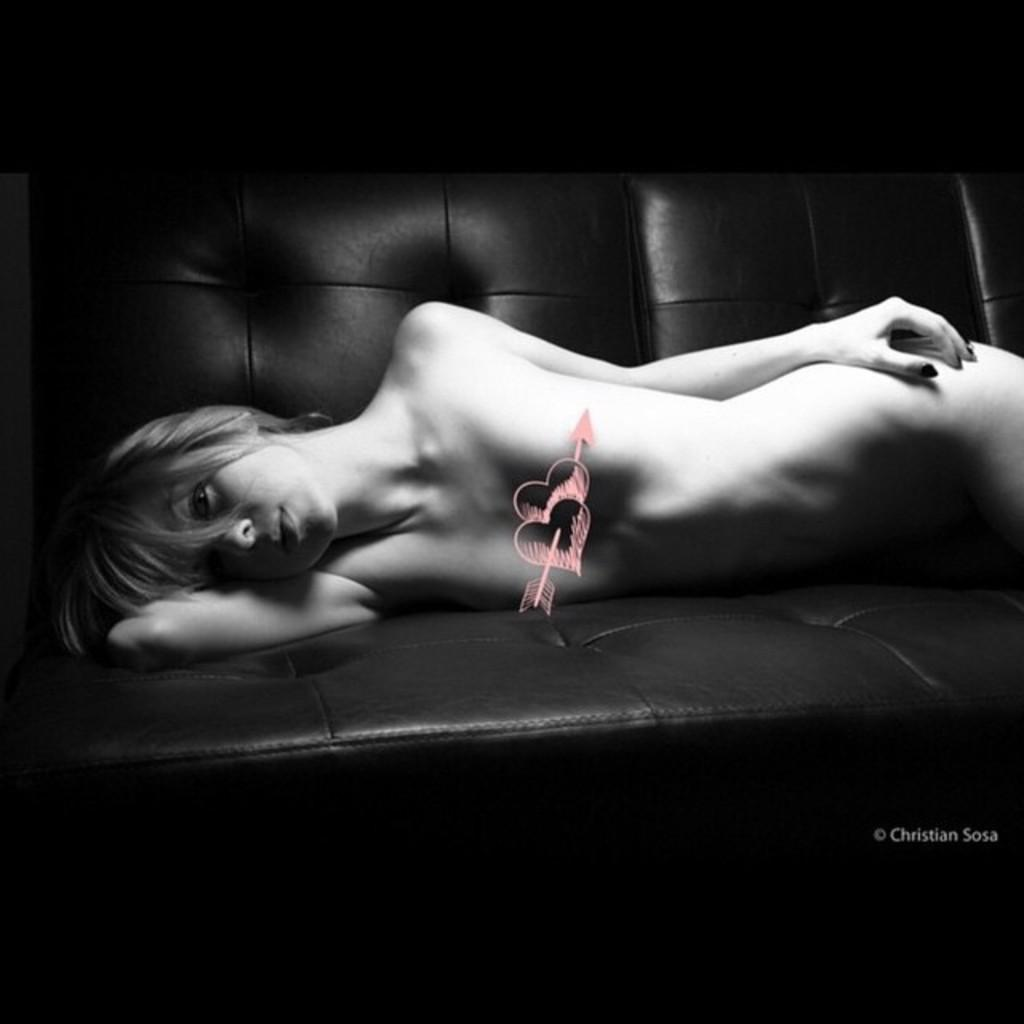What is the main subject of the image? The main subject of the image is a woman. What is the woman doing in the image? The woman is lying on a sofa bed. What is the woman wearing in the image? The woman is naked in the image. What type of bag can be seen in the image? There is no bag present in the image. What shocking event is happening in the image? There is no shocking event happening in the image; it simply depicts a woman lying on a sofa bed. 